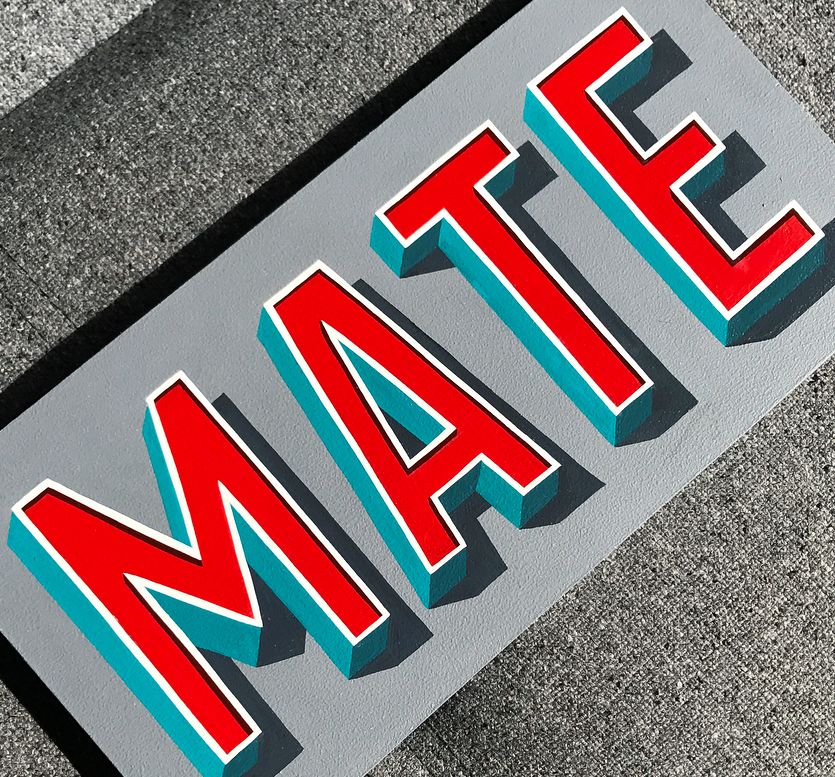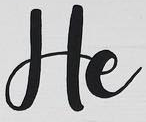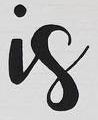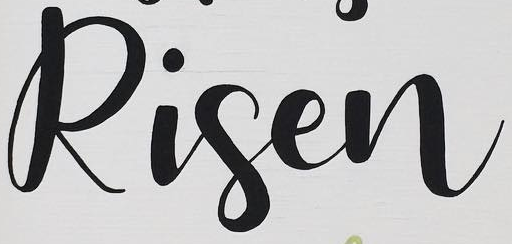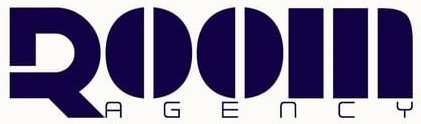Read the text from these images in sequence, separated by a semicolon. MATE; He; is; Risen; ROOM 